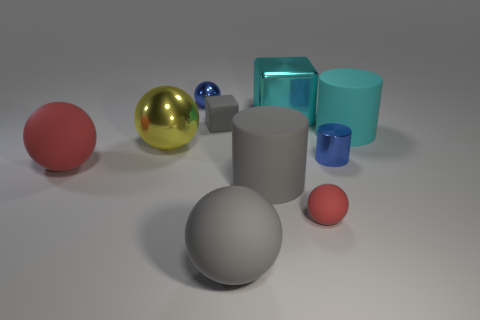Subtract all brown cylinders. How many red balls are left? 2 Subtract 1 cylinders. How many cylinders are left? 2 Subtract all big gray spheres. How many spheres are left? 4 Subtract all gray balls. How many balls are left? 4 Subtract all green spheres. Subtract all brown blocks. How many spheres are left? 5 Subtract all cubes. How many objects are left? 8 Add 8 yellow balls. How many yellow balls exist? 9 Subtract 0 green cubes. How many objects are left? 10 Subtract all cyan shiny cubes. Subtract all large metallic blocks. How many objects are left? 8 Add 2 shiny objects. How many shiny objects are left? 6 